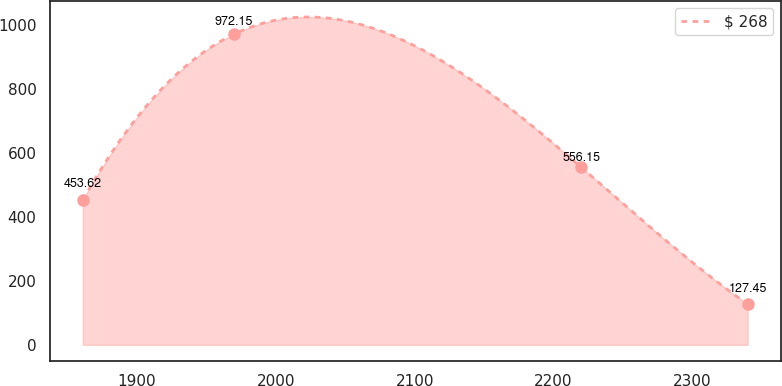<chart> <loc_0><loc_0><loc_500><loc_500><line_chart><ecel><fcel>$ 268<nl><fcel>1860.93<fcel>453.62<nl><fcel>1969.71<fcel>972.15<nl><fcel>2219.83<fcel>556.15<nl><fcel>2339.83<fcel>127.45<nl></chart> 